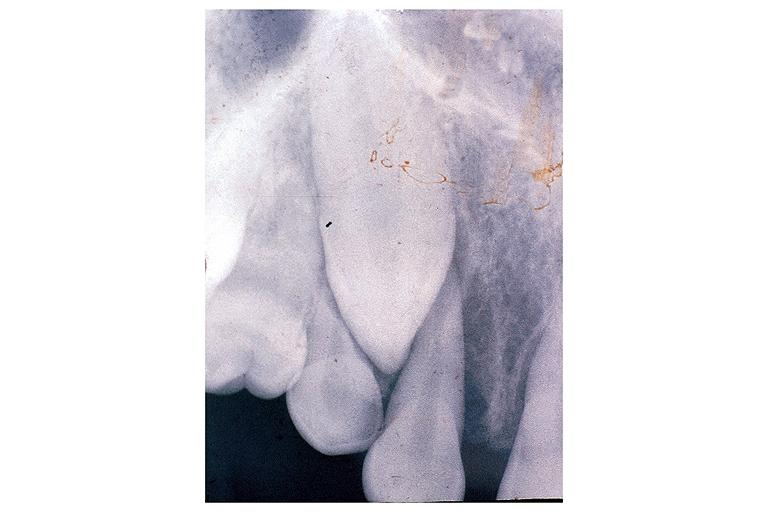what is present?
Answer the question using a single word or phrase. Oral 